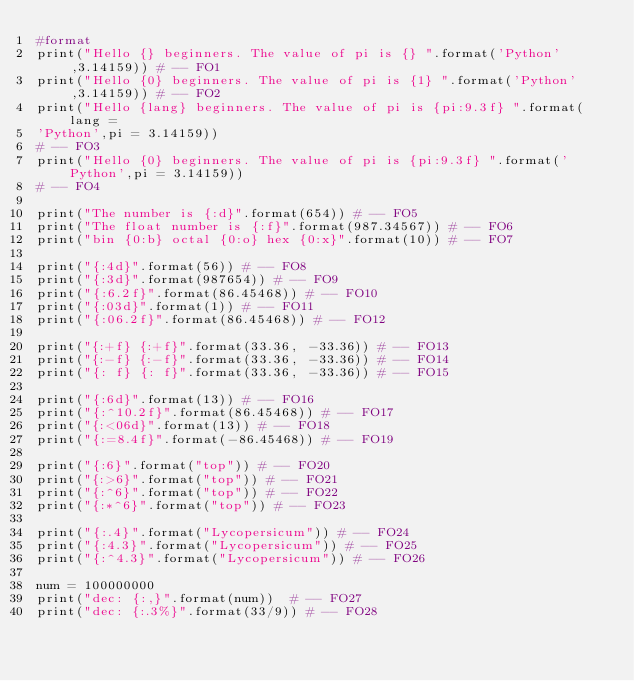Convert code to text. <code><loc_0><loc_0><loc_500><loc_500><_Python_>#format
print("Hello {} beginners. The value of pi is {} ".format('Python',3.14159)) # -- FO1
print("Hello {0} beginners. The value of pi is {1} ".format('Python',3.14159)) # -- FO2
print("Hello {lang} beginners. The value of pi is {pi:9.3f} ".format(lang = 
'Python',pi = 3.14159)) 
# -- FO3
print("Hello {0} beginners. The value of pi is {pi:9.3f} ".format('Python',pi = 3.14159)) 
# -- FO4

print("The number is {:d}".format(654)) # -- FO5
print("The float number is {:f}".format(987.34567)) # -- FO6
print("bin {0:b} octal {0:o} hex {0:x}".format(10)) # -- FO7

print("{:4d}".format(56)) # -- FO8
print("{:3d}".format(987654)) # -- FO9
print("{:6.2f}".format(86.45468)) # -- FO10
print("{:03d}".format(1)) # -- FO11
print("{:06.2f}".format(86.45468)) # -- FO12

print("{:+f} {:+f}".format(33.36, -33.36)) # -- FO13
print("{:-f} {:-f}".format(33.36, -33.36)) # -- FO14
print("{: f} {: f}".format(33.36, -33.36)) # -- FO15

print("{:6d}".format(13)) # -- FO16
print("{:^10.2f}".format(86.45468)) # -- FO17
print("{:<06d}".format(13)) # -- FO18
print("{:=8.4f}".format(-86.45468)) # -- FO19

print("{:6}".format("top")) # -- FO20
print("{:>6}".format("top")) # -- FO21
print("{:^6}".format("top")) # -- FO22
print("{:*^6}".format("top")) # -- FO23

print("{:.4}".format("Lycopersicum")) # -- FO24
print("{:4.3}".format("Lycopersicum")) # -- FO25
print("{:^4.3}".format("Lycopersicum")) # -- FO26

num = 100000000  
print("dec: {:,}".format(num))  # -- FO27
print("dec: {:.3%}".format(33/9)) # -- FO28</code> 